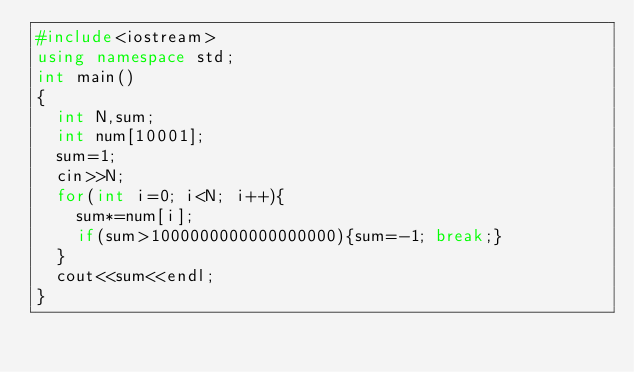<code> <loc_0><loc_0><loc_500><loc_500><_C++_>#include<iostream>
using namespace std;
int main()
{
  int N,sum;
  int num[10001];
  sum=1;
  cin>>N;
  for(int i=0; i<N; i++){
    sum*=num[i];
    if(sum>1000000000000000000){sum=-1; break;}
  }
  cout<<sum<<endl;
}</code> 